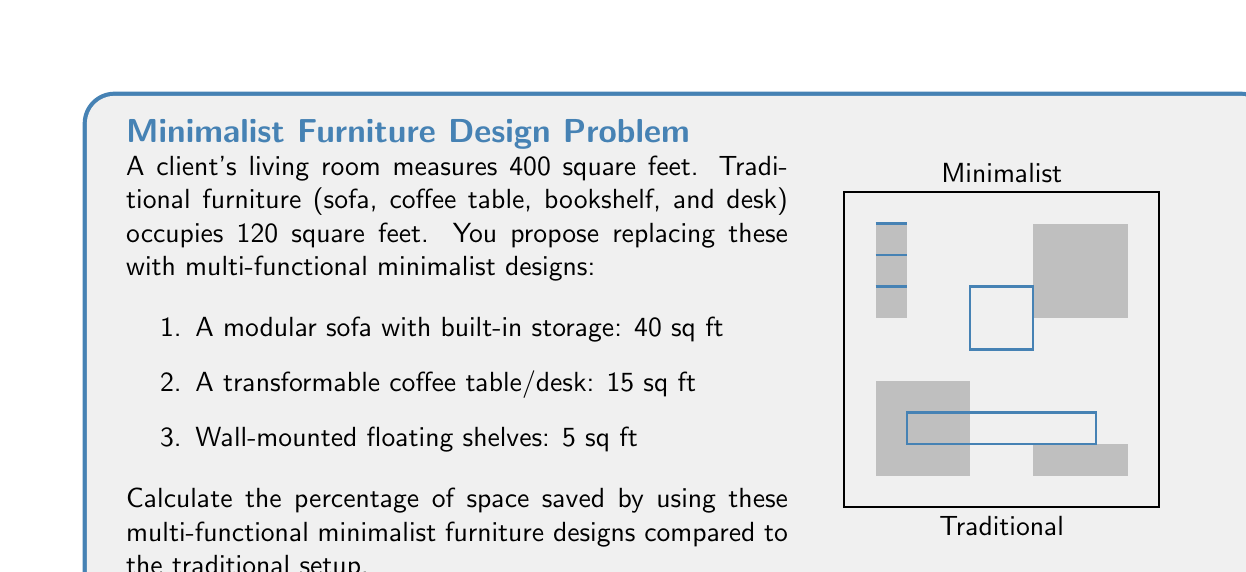Solve this math problem. Let's approach this step-by-step:

1) Calculate the total space occupied by traditional furniture:
   $$ \text{Traditional space} = 120 \text{ sq ft} $$

2) Calculate the total space occupied by minimalist furniture:
   $$ \text{Minimalist space} = 40 + 15 + 5 = 60 \text{ sq ft} $$

3) Calculate the space saved:
   $$ \text{Space saved} = \text{Traditional space} - \text{Minimalist space} $$
   $$ \text{Space saved} = 120 - 60 = 60 \text{ sq ft} $$

4) Calculate the percentage of space saved:
   $$ \text{Percentage saved} = \frac{\text{Space saved}}{\text{Traditional space}} \times 100\% $$
   $$ \text{Percentage saved} = \frac{60}{120} \times 100\% = 0.5 \times 100\% = 50\% $$

Therefore, by using multi-functional minimalist furniture designs, the client saves 50% of the space previously occupied by traditional furniture.
Answer: 50% 